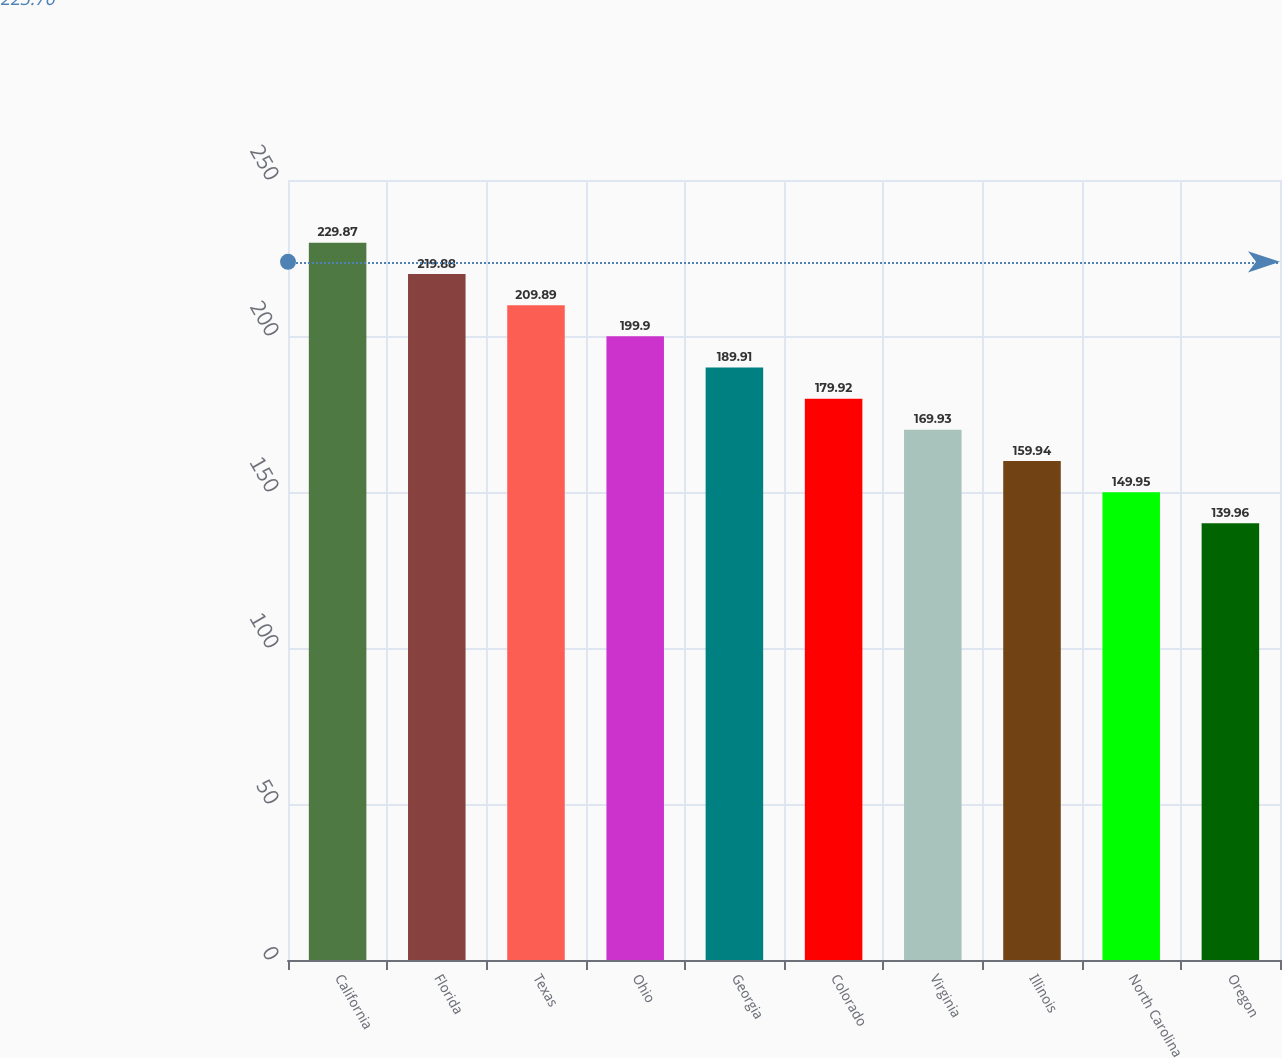Convert chart. <chart><loc_0><loc_0><loc_500><loc_500><bar_chart><fcel>California<fcel>Florida<fcel>Texas<fcel>Ohio<fcel>Georgia<fcel>Colorado<fcel>Virginia<fcel>Illinois<fcel>North Carolina<fcel>Oregon<nl><fcel>229.87<fcel>219.88<fcel>209.89<fcel>199.9<fcel>189.91<fcel>179.92<fcel>169.93<fcel>159.94<fcel>149.95<fcel>139.96<nl></chart> 